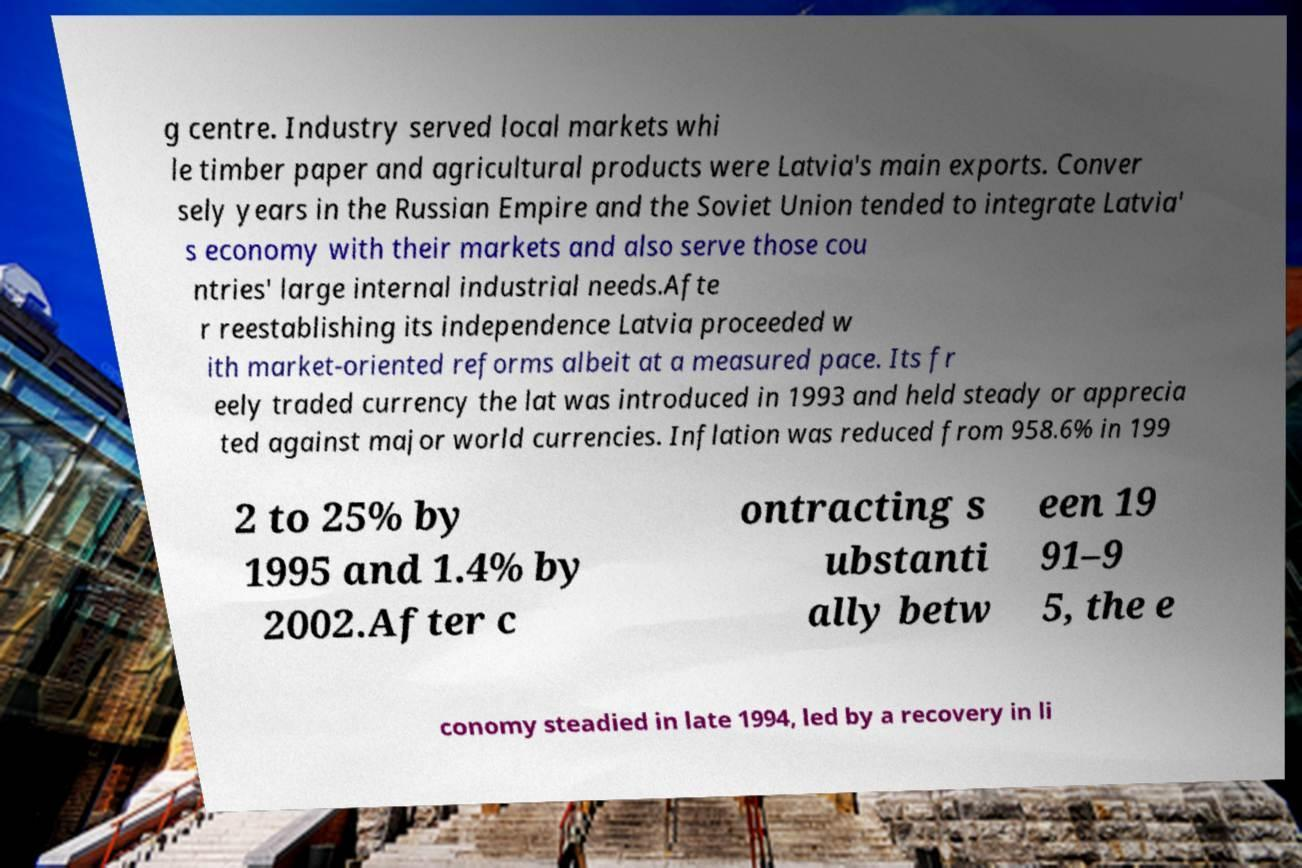There's text embedded in this image that I need extracted. Can you transcribe it verbatim? g centre. Industry served local markets whi le timber paper and agricultural products were Latvia's main exports. Conver sely years in the Russian Empire and the Soviet Union tended to integrate Latvia' s economy with their markets and also serve those cou ntries' large internal industrial needs.Afte r reestablishing its independence Latvia proceeded w ith market-oriented reforms albeit at a measured pace. Its fr eely traded currency the lat was introduced in 1993 and held steady or apprecia ted against major world currencies. Inflation was reduced from 958.6% in 199 2 to 25% by 1995 and 1.4% by 2002.After c ontracting s ubstanti ally betw een 19 91–9 5, the e conomy steadied in late 1994, led by a recovery in li 